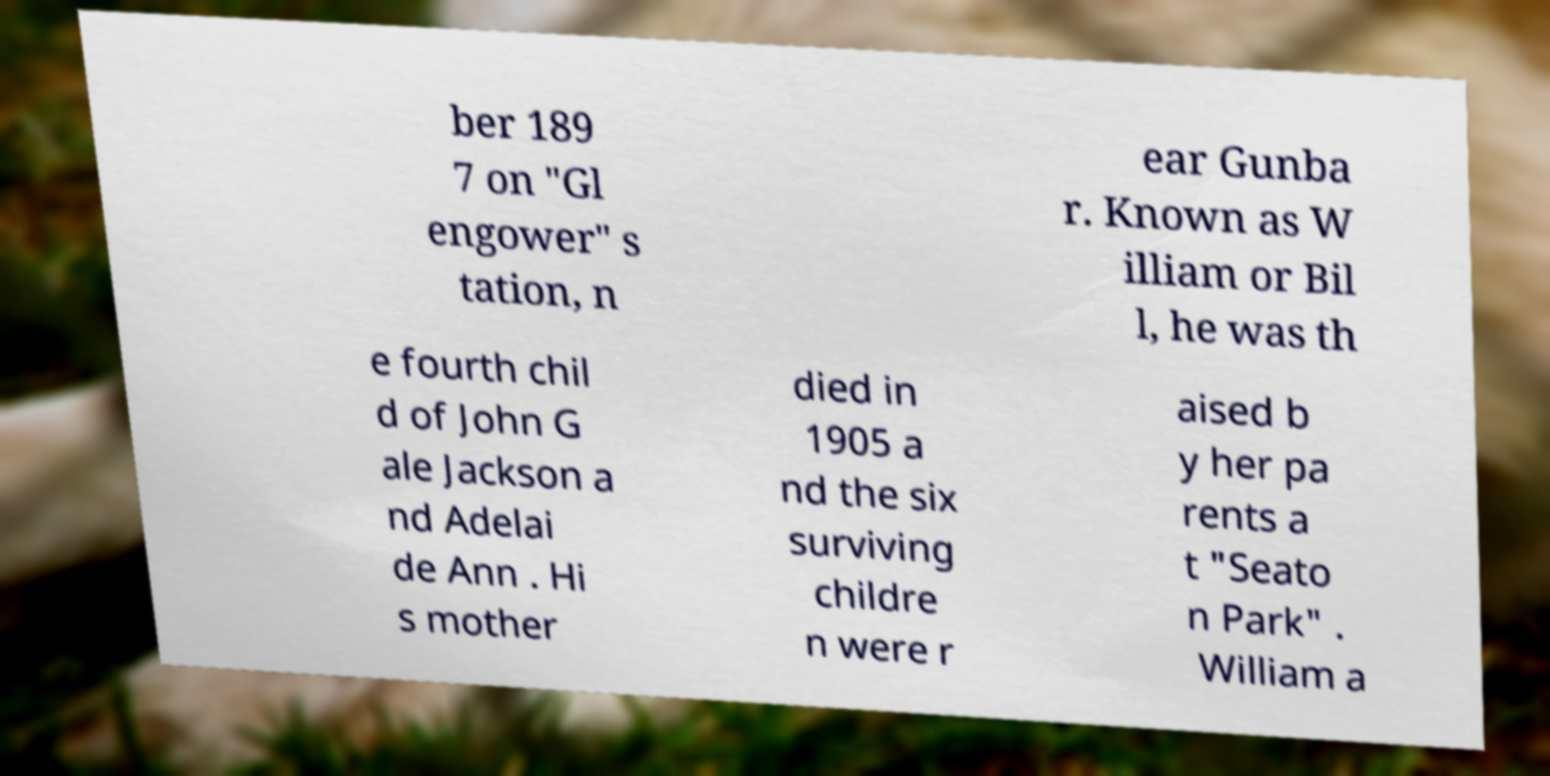What messages or text are displayed in this image? I need them in a readable, typed format. ber 189 7 on "Gl engower" s tation, n ear Gunba r. Known as W illiam or Bil l, he was th e fourth chil d of John G ale Jackson a nd Adelai de Ann . Hi s mother died in 1905 a nd the six surviving childre n were r aised b y her pa rents a t "Seato n Park" . William a 